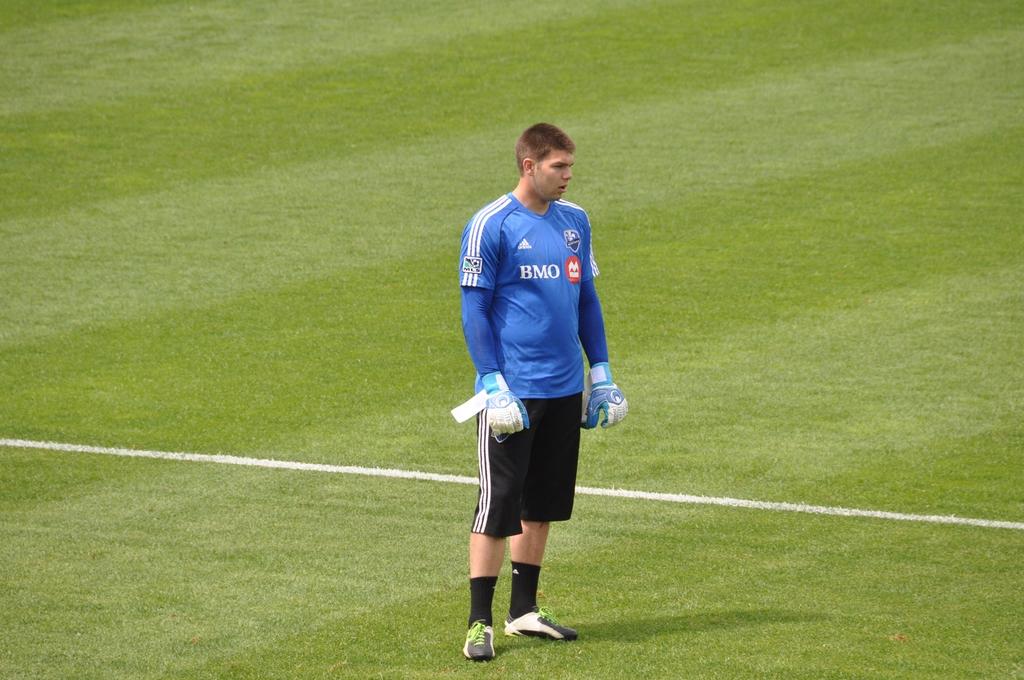What 3 letters are written in white on the player's jersey?
Provide a succinct answer. Bmo. 